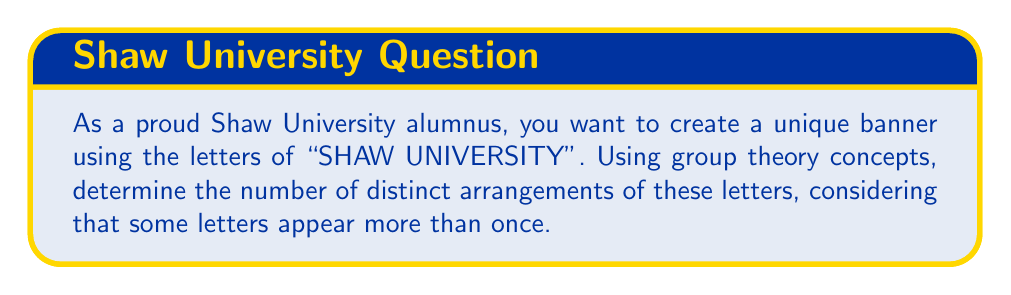Can you answer this question? To solve this problem, we'll use the concept of permutations with repetition from group theory.

1) First, let's count the frequency of each letter in "SHAW UNIVERSITY":
   S: 1, H: 1, A: 1, W: 1, U: 2, N: 1, I: 2, V: 1, E: 1, R: 1, T: 1, Y: 1

2) The total number of letters is 14.

3) In group theory, for permutations with repetition, we use the following formula:

   $$\frac{n!}{n_1! \cdot n_2! \cdot ... \cdot n_k!}$$

   Where:
   $n$ is the total number of elements
   $n_1, n_2, ..., n_k$ are the numbers of each repeated element

4) In our case:
   $$\frac{14!}{1! \cdot 1! \cdot 1! \cdot 1! \cdot 2! \cdot 1! \cdot 2! \cdot 1! \cdot 1! \cdot 1! \cdot 1! \cdot 1!}$$

5) Simplifying:
   $$\frac{14!}{(2! \cdot 2!)}$$

6) Calculating:
   $$\frac{14!}{4} = 21,771,700,800$$

Therefore, there are 21,771,700,800 unique ways to arrange the letters in "SHAW UNIVERSITY".
Answer: 21,771,700,800 